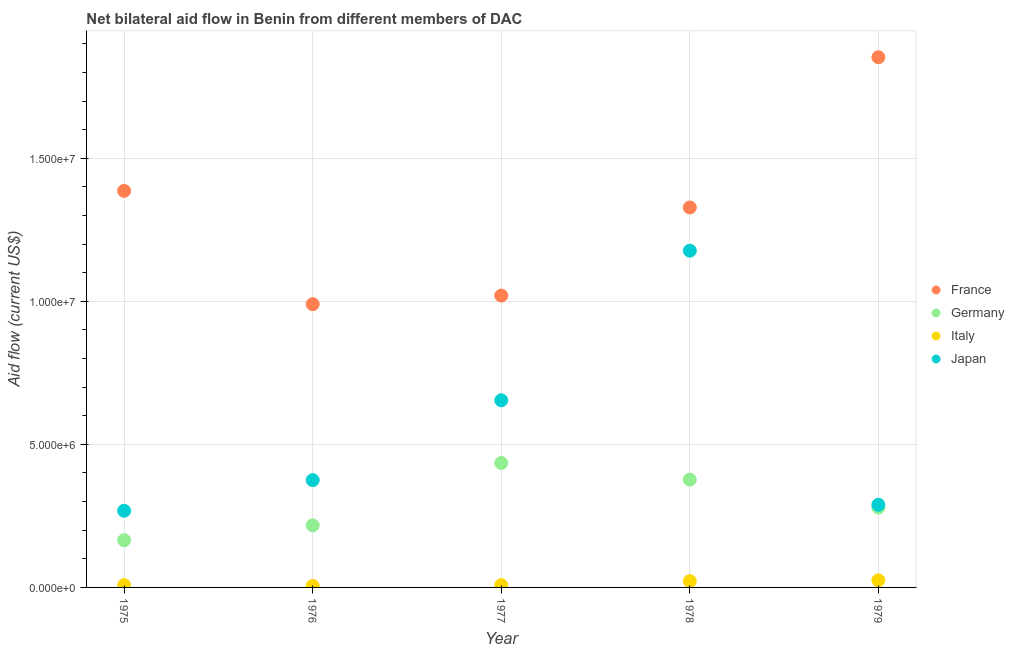How many different coloured dotlines are there?
Keep it short and to the point. 4. Is the number of dotlines equal to the number of legend labels?
Your response must be concise. Yes. What is the amount of aid given by germany in 1979?
Provide a short and direct response. 2.79e+06. Across all years, what is the maximum amount of aid given by germany?
Keep it short and to the point. 4.35e+06. Across all years, what is the minimum amount of aid given by germany?
Provide a short and direct response. 1.65e+06. In which year was the amount of aid given by italy maximum?
Make the answer very short. 1979. In which year was the amount of aid given by france minimum?
Your answer should be compact. 1976. What is the total amount of aid given by germany in the graph?
Offer a terse response. 1.47e+07. What is the difference between the amount of aid given by italy in 1975 and that in 1979?
Offer a very short reply. -1.70e+05. What is the difference between the amount of aid given by germany in 1979 and the amount of aid given by italy in 1976?
Give a very brief answer. 2.74e+06. What is the average amount of aid given by germany per year?
Give a very brief answer. 2.95e+06. In the year 1977, what is the difference between the amount of aid given by italy and amount of aid given by japan?
Provide a short and direct response. -6.46e+06. What is the ratio of the amount of aid given by germany in 1977 to that in 1979?
Your response must be concise. 1.56. What is the difference between the highest and the second highest amount of aid given by germany?
Your response must be concise. 5.80e+05. What is the difference between the highest and the lowest amount of aid given by japan?
Keep it short and to the point. 9.09e+06. In how many years, is the amount of aid given by italy greater than the average amount of aid given by italy taken over all years?
Ensure brevity in your answer.  2. Is the sum of the amount of aid given by france in 1976 and 1977 greater than the maximum amount of aid given by germany across all years?
Your response must be concise. Yes. How many dotlines are there?
Provide a short and direct response. 4. How many years are there in the graph?
Offer a terse response. 5. Are the values on the major ticks of Y-axis written in scientific E-notation?
Your answer should be very brief. Yes. Does the graph contain any zero values?
Give a very brief answer. No. Does the graph contain grids?
Give a very brief answer. Yes. How are the legend labels stacked?
Keep it short and to the point. Vertical. What is the title of the graph?
Make the answer very short. Net bilateral aid flow in Benin from different members of DAC. What is the label or title of the X-axis?
Give a very brief answer. Year. What is the label or title of the Y-axis?
Ensure brevity in your answer.  Aid flow (current US$). What is the Aid flow (current US$) in France in 1975?
Your response must be concise. 1.39e+07. What is the Aid flow (current US$) in Germany in 1975?
Your response must be concise. 1.65e+06. What is the Aid flow (current US$) in Italy in 1975?
Offer a terse response. 8.00e+04. What is the Aid flow (current US$) of Japan in 1975?
Offer a very short reply. 2.68e+06. What is the Aid flow (current US$) in France in 1976?
Offer a very short reply. 9.90e+06. What is the Aid flow (current US$) in Germany in 1976?
Your answer should be compact. 2.17e+06. What is the Aid flow (current US$) of Japan in 1976?
Your answer should be very brief. 3.75e+06. What is the Aid flow (current US$) in France in 1977?
Give a very brief answer. 1.02e+07. What is the Aid flow (current US$) in Germany in 1977?
Your answer should be very brief. 4.35e+06. What is the Aid flow (current US$) in Italy in 1977?
Make the answer very short. 8.00e+04. What is the Aid flow (current US$) in Japan in 1977?
Offer a terse response. 6.54e+06. What is the Aid flow (current US$) in France in 1978?
Your response must be concise. 1.33e+07. What is the Aid flow (current US$) of Germany in 1978?
Keep it short and to the point. 3.77e+06. What is the Aid flow (current US$) of Italy in 1978?
Provide a succinct answer. 2.20e+05. What is the Aid flow (current US$) in Japan in 1978?
Your answer should be compact. 1.18e+07. What is the Aid flow (current US$) in France in 1979?
Your answer should be very brief. 1.85e+07. What is the Aid flow (current US$) in Germany in 1979?
Your answer should be very brief. 2.79e+06. What is the Aid flow (current US$) of Japan in 1979?
Your answer should be very brief. 2.89e+06. Across all years, what is the maximum Aid flow (current US$) in France?
Offer a very short reply. 1.85e+07. Across all years, what is the maximum Aid flow (current US$) in Germany?
Offer a very short reply. 4.35e+06. Across all years, what is the maximum Aid flow (current US$) in Japan?
Your answer should be very brief. 1.18e+07. Across all years, what is the minimum Aid flow (current US$) in France?
Your answer should be very brief. 9.90e+06. Across all years, what is the minimum Aid flow (current US$) in Germany?
Keep it short and to the point. 1.65e+06. Across all years, what is the minimum Aid flow (current US$) of Italy?
Your answer should be compact. 5.00e+04. Across all years, what is the minimum Aid flow (current US$) of Japan?
Your answer should be compact. 2.68e+06. What is the total Aid flow (current US$) of France in the graph?
Keep it short and to the point. 6.58e+07. What is the total Aid flow (current US$) of Germany in the graph?
Provide a succinct answer. 1.47e+07. What is the total Aid flow (current US$) of Italy in the graph?
Give a very brief answer. 6.80e+05. What is the total Aid flow (current US$) of Japan in the graph?
Give a very brief answer. 2.76e+07. What is the difference between the Aid flow (current US$) in France in 1975 and that in 1976?
Your answer should be compact. 3.96e+06. What is the difference between the Aid flow (current US$) of Germany in 1975 and that in 1976?
Offer a very short reply. -5.20e+05. What is the difference between the Aid flow (current US$) in Italy in 1975 and that in 1976?
Provide a short and direct response. 3.00e+04. What is the difference between the Aid flow (current US$) of Japan in 1975 and that in 1976?
Ensure brevity in your answer.  -1.07e+06. What is the difference between the Aid flow (current US$) in France in 1975 and that in 1977?
Make the answer very short. 3.66e+06. What is the difference between the Aid flow (current US$) in Germany in 1975 and that in 1977?
Your answer should be compact. -2.70e+06. What is the difference between the Aid flow (current US$) in Italy in 1975 and that in 1977?
Give a very brief answer. 0. What is the difference between the Aid flow (current US$) in Japan in 1975 and that in 1977?
Ensure brevity in your answer.  -3.86e+06. What is the difference between the Aid flow (current US$) in France in 1975 and that in 1978?
Your response must be concise. 5.80e+05. What is the difference between the Aid flow (current US$) of Germany in 1975 and that in 1978?
Keep it short and to the point. -2.12e+06. What is the difference between the Aid flow (current US$) of Italy in 1975 and that in 1978?
Your answer should be compact. -1.40e+05. What is the difference between the Aid flow (current US$) in Japan in 1975 and that in 1978?
Make the answer very short. -9.09e+06. What is the difference between the Aid flow (current US$) of France in 1975 and that in 1979?
Your response must be concise. -4.67e+06. What is the difference between the Aid flow (current US$) of Germany in 1975 and that in 1979?
Your answer should be compact. -1.14e+06. What is the difference between the Aid flow (current US$) of France in 1976 and that in 1977?
Your answer should be compact. -3.00e+05. What is the difference between the Aid flow (current US$) of Germany in 1976 and that in 1977?
Your answer should be compact. -2.18e+06. What is the difference between the Aid flow (current US$) of Japan in 1976 and that in 1977?
Your response must be concise. -2.79e+06. What is the difference between the Aid flow (current US$) of France in 1976 and that in 1978?
Offer a very short reply. -3.38e+06. What is the difference between the Aid flow (current US$) in Germany in 1976 and that in 1978?
Keep it short and to the point. -1.60e+06. What is the difference between the Aid flow (current US$) in Italy in 1976 and that in 1978?
Your answer should be very brief. -1.70e+05. What is the difference between the Aid flow (current US$) of Japan in 1976 and that in 1978?
Keep it short and to the point. -8.02e+06. What is the difference between the Aid flow (current US$) of France in 1976 and that in 1979?
Offer a very short reply. -8.63e+06. What is the difference between the Aid flow (current US$) in Germany in 1976 and that in 1979?
Offer a very short reply. -6.20e+05. What is the difference between the Aid flow (current US$) in Japan in 1976 and that in 1979?
Offer a very short reply. 8.60e+05. What is the difference between the Aid flow (current US$) of France in 1977 and that in 1978?
Keep it short and to the point. -3.08e+06. What is the difference between the Aid flow (current US$) of Germany in 1977 and that in 1978?
Make the answer very short. 5.80e+05. What is the difference between the Aid flow (current US$) of Japan in 1977 and that in 1978?
Offer a terse response. -5.23e+06. What is the difference between the Aid flow (current US$) of France in 1977 and that in 1979?
Provide a short and direct response. -8.33e+06. What is the difference between the Aid flow (current US$) in Germany in 1977 and that in 1979?
Your answer should be compact. 1.56e+06. What is the difference between the Aid flow (current US$) of Japan in 1977 and that in 1979?
Your answer should be compact. 3.65e+06. What is the difference between the Aid flow (current US$) of France in 1978 and that in 1979?
Ensure brevity in your answer.  -5.25e+06. What is the difference between the Aid flow (current US$) of Germany in 1978 and that in 1979?
Offer a very short reply. 9.80e+05. What is the difference between the Aid flow (current US$) in Japan in 1978 and that in 1979?
Offer a very short reply. 8.88e+06. What is the difference between the Aid flow (current US$) in France in 1975 and the Aid flow (current US$) in Germany in 1976?
Provide a short and direct response. 1.17e+07. What is the difference between the Aid flow (current US$) in France in 1975 and the Aid flow (current US$) in Italy in 1976?
Your response must be concise. 1.38e+07. What is the difference between the Aid flow (current US$) of France in 1975 and the Aid flow (current US$) of Japan in 1976?
Give a very brief answer. 1.01e+07. What is the difference between the Aid flow (current US$) in Germany in 1975 and the Aid flow (current US$) in Italy in 1976?
Offer a very short reply. 1.60e+06. What is the difference between the Aid flow (current US$) of Germany in 1975 and the Aid flow (current US$) of Japan in 1976?
Your answer should be compact. -2.10e+06. What is the difference between the Aid flow (current US$) of Italy in 1975 and the Aid flow (current US$) of Japan in 1976?
Give a very brief answer. -3.67e+06. What is the difference between the Aid flow (current US$) of France in 1975 and the Aid flow (current US$) of Germany in 1977?
Your answer should be compact. 9.51e+06. What is the difference between the Aid flow (current US$) in France in 1975 and the Aid flow (current US$) in Italy in 1977?
Keep it short and to the point. 1.38e+07. What is the difference between the Aid flow (current US$) of France in 1975 and the Aid flow (current US$) of Japan in 1977?
Make the answer very short. 7.32e+06. What is the difference between the Aid flow (current US$) in Germany in 1975 and the Aid flow (current US$) in Italy in 1977?
Your response must be concise. 1.57e+06. What is the difference between the Aid flow (current US$) of Germany in 1975 and the Aid flow (current US$) of Japan in 1977?
Give a very brief answer. -4.89e+06. What is the difference between the Aid flow (current US$) of Italy in 1975 and the Aid flow (current US$) of Japan in 1977?
Your answer should be compact. -6.46e+06. What is the difference between the Aid flow (current US$) of France in 1975 and the Aid flow (current US$) of Germany in 1978?
Provide a succinct answer. 1.01e+07. What is the difference between the Aid flow (current US$) in France in 1975 and the Aid flow (current US$) in Italy in 1978?
Offer a terse response. 1.36e+07. What is the difference between the Aid flow (current US$) of France in 1975 and the Aid flow (current US$) of Japan in 1978?
Make the answer very short. 2.09e+06. What is the difference between the Aid flow (current US$) in Germany in 1975 and the Aid flow (current US$) in Italy in 1978?
Give a very brief answer. 1.43e+06. What is the difference between the Aid flow (current US$) in Germany in 1975 and the Aid flow (current US$) in Japan in 1978?
Provide a short and direct response. -1.01e+07. What is the difference between the Aid flow (current US$) of Italy in 1975 and the Aid flow (current US$) of Japan in 1978?
Offer a terse response. -1.17e+07. What is the difference between the Aid flow (current US$) of France in 1975 and the Aid flow (current US$) of Germany in 1979?
Offer a very short reply. 1.11e+07. What is the difference between the Aid flow (current US$) of France in 1975 and the Aid flow (current US$) of Italy in 1979?
Make the answer very short. 1.36e+07. What is the difference between the Aid flow (current US$) of France in 1975 and the Aid flow (current US$) of Japan in 1979?
Your answer should be compact. 1.10e+07. What is the difference between the Aid flow (current US$) of Germany in 1975 and the Aid flow (current US$) of Italy in 1979?
Your response must be concise. 1.40e+06. What is the difference between the Aid flow (current US$) of Germany in 1975 and the Aid flow (current US$) of Japan in 1979?
Provide a short and direct response. -1.24e+06. What is the difference between the Aid flow (current US$) of Italy in 1975 and the Aid flow (current US$) of Japan in 1979?
Give a very brief answer. -2.81e+06. What is the difference between the Aid flow (current US$) in France in 1976 and the Aid flow (current US$) in Germany in 1977?
Offer a terse response. 5.55e+06. What is the difference between the Aid flow (current US$) in France in 1976 and the Aid flow (current US$) in Italy in 1977?
Give a very brief answer. 9.82e+06. What is the difference between the Aid flow (current US$) in France in 1976 and the Aid flow (current US$) in Japan in 1977?
Your response must be concise. 3.36e+06. What is the difference between the Aid flow (current US$) of Germany in 1976 and the Aid flow (current US$) of Italy in 1977?
Your answer should be compact. 2.09e+06. What is the difference between the Aid flow (current US$) in Germany in 1976 and the Aid flow (current US$) in Japan in 1977?
Ensure brevity in your answer.  -4.37e+06. What is the difference between the Aid flow (current US$) of Italy in 1976 and the Aid flow (current US$) of Japan in 1977?
Provide a short and direct response. -6.49e+06. What is the difference between the Aid flow (current US$) in France in 1976 and the Aid flow (current US$) in Germany in 1978?
Make the answer very short. 6.13e+06. What is the difference between the Aid flow (current US$) of France in 1976 and the Aid flow (current US$) of Italy in 1978?
Give a very brief answer. 9.68e+06. What is the difference between the Aid flow (current US$) in France in 1976 and the Aid flow (current US$) in Japan in 1978?
Make the answer very short. -1.87e+06. What is the difference between the Aid flow (current US$) in Germany in 1976 and the Aid flow (current US$) in Italy in 1978?
Make the answer very short. 1.95e+06. What is the difference between the Aid flow (current US$) of Germany in 1976 and the Aid flow (current US$) of Japan in 1978?
Your answer should be very brief. -9.60e+06. What is the difference between the Aid flow (current US$) in Italy in 1976 and the Aid flow (current US$) in Japan in 1978?
Keep it short and to the point. -1.17e+07. What is the difference between the Aid flow (current US$) of France in 1976 and the Aid flow (current US$) of Germany in 1979?
Your answer should be compact. 7.11e+06. What is the difference between the Aid flow (current US$) of France in 1976 and the Aid flow (current US$) of Italy in 1979?
Give a very brief answer. 9.65e+06. What is the difference between the Aid flow (current US$) of France in 1976 and the Aid flow (current US$) of Japan in 1979?
Your answer should be very brief. 7.01e+06. What is the difference between the Aid flow (current US$) in Germany in 1976 and the Aid flow (current US$) in Italy in 1979?
Offer a terse response. 1.92e+06. What is the difference between the Aid flow (current US$) in Germany in 1976 and the Aid flow (current US$) in Japan in 1979?
Make the answer very short. -7.20e+05. What is the difference between the Aid flow (current US$) of Italy in 1976 and the Aid flow (current US$) of Japan in 1979?
Offer a terse response. -2.84e+06. What is the difference between the Aid flow (current US$) in France in 1977 and the Aid flow (current US$) in Germany in 1978?
Ensure brevity in your answer.  6.43e+06. What is the difference between the Aid flow (current US$) in France in 1977 and the Aid flow (current US$) in Italy in 1978?
Ensure brevity in your answer.  9.98e+06. What is the difference between the Aid flow (current US$) in France in 1977 and the Aid flow (current US$) in Japan in 1978?
Provide a short and direct response. -1.57e+06. What is the difference between the Aid flow (current US$) of Germany in 1977 and the Aid flow (current US$) of Italy in 1978?
Keep it short and to the point. 4.13e+06. What is the difference between the Aid flow (current US$) in Germany in 1977 and the Aid flow (current US$) in Japan in 1978?
Give a very brief answer. -7.42e+06. What is the difference between the Aid flow (current US$) in Italy in 1977 and the Aid flow (current US$) in Japan in 1978?
Keep it short and to the point. -1.17e+07. What is the difference between the Aid flow (current US$) of France in 1977 and the Aid flow (current US$) of Germany in 1979?
Offer a very short reply. 7.41e+06. What is the difference between the Aid flow (current US$) of France in 1977 and the Aid flow (current US$) of Italy in 1979?
Give a very brief answer. 9.95e+06. What is the difference between the Aid flow (current US$) in France in 1977 and the Aid flow (current US$) in Japan in 1979?
Provide a succinct answer. 7.31e+06. What is the difference between the Aid flow (current US$) in Germany in 1977 and the Aid flow (current US$) in Italy in 1979?
Keep it short and to the point. 4.10e+06. What is the difference between the Aid flow (current US$) of Germany in 1977 and the Aid flow (current US$) of Japan in 1979?
Offer a very short reply. 1.46e+06. What is the difference between the Aid flow (current US$) of Italy in 1977 and the Aid flow (current US$) of Japan in 1979?
Make the answer very short. -2.81e+06. What is the difference between the Aid flow (current US$) of France in 1978 and the Aid flow (current US$) of Germany in 1979?
Your answer should be compact. 1.05e+07. What is the difference between the Aid flow (current US$) in France in 1978 and the Aid flow (current US$) in Italy in 1979?
Your answer should be compact. 1.30e+07. What is the difference between the Aid flow (current US$) of France in 1978 and the Aid flow (current US$) of Japan in 1979?
Provide a short and direct response. 1.04e+07. What is the difference between the Aid flow (current US$) in Germany in 1978 and the Aid flow (current US$) in Italy in 1979?
Ensure brevity in your answer.  3.52e+06. What is the difference between the Aid flow (current US$) in Germany in 1978 and the Aid flow (current US$) in Japan in 1979?
Provide a succinct answer. 8.80e+05. What is the difference between the Aid flow (current US$) in Italy in 1978 and the Aid flow (current US$) in Japan in 1979?
Keep it short and to the point. -2.67e+06. What is the average Aid flow (current US$) of France per year?
Keep it short and to the point. 1.32e+07. What is the average Aid flow (current US$) in Germany per year?
Provide a short and direct response. 2.95e+06. What is the average Aid flow (current US$) of Italy per year?
Offer a very short reply. 1.36e+05. What is the average Aid flow (current US$) of Japan per year?
Make the answer very short. 5.53e+06. In the year 1975, what is the difference between the Aid flow (current US$) in France and Aid flow (current US$) in Germany?
Offer a very short reply. 1.22e+07. In the year 1975, what is the difference between the Aid flow (current US$) in France and Aid flow (current US$) in Italy?
Offer a very short reply. 1.38e+07. In the year 1975, what is the difference between the Aid flow (current US$) of France and Aid flow (current US$) of Japan?
Ensure brevity in your answer.  1.12e+07. In the year 1975, what is the difference between the Aid flow (current US$) of Germany and Aid flow (current US$) of Italy?
Give a very brief answer. 1.57e+06. In the year 1975, what is the difference between the Aid flow (current US$) of Germany and Aid flow (current US$) of Japan?
Offer a terse response. -1.03e+06. In the year 1975, what is the difference between the Aid flow (current US$) in Italy and Aid flow (current US$) in Japan?
Your response must be concise. -2.60e+06. In the year 1976, what is the difference between the Aid flow (current US$) of France and Aid flow (current US$) of Germany?
Your answer should be very brief. 7.73e+06. In the year 1976, what is the difference between the Aid flow (current US$) in France and Aid flow (current US$) in Italy?
Your answer should be compact. 9.85e+06. In the year 1976, what is the difference between the Aid flow (current US$) of France and Aid flow (current US$) of Japan?
Offer a very short reply. 6.15e+06. In the year 1976, what is the difference between the Aid flow (current US$) in Germany and Aid flow (current US$) in Italy?
Ensure brevity in your answer.  2.12e+06. In the year 1976, what is the difference between the Aid flow (current US$) in Germany and Aid flow (current US$) in Japan?
Give a very brief answer. -1.58e+06. In the year 1976, what is the difference between the Aid flow (current US$) in Italy and Aid flow (current US$) in Japan?
Your answer should be compact. -3.70e+06. In the year 1977, what is the difference between the Aid flow (current US$) in France and Aid flow (current US$) in Germany?
Make the answer very short. 5.85e+06. In the year 1977, what is the difference between the Aid flow (current US$) of France and Aid flow (current US$) of Italy?
Make the answer very short. 1.01e+07. In the year 1977, what is the difference between the Aid flow (current US$) of France and Aid flow (current US$) of Japan?
Make the answer very short. 3.66e+06. In the year 1977, what is the difference between the Aid flow (current US$) of Germany and Aid flow (current US$) of Italy?
Ensure brevity in your answer.  4.27e+06. In the year 1977, what is the difference between the Aid flow (current US$) of Germany and Aid flow (current US$) of Japan?
Your answer should be very brief. -2.19e+06. In the year 1977, what is the difference between the Aid flow (current US$) of Italy and Aid flow (current US$) of Japan?
Make the answer very short. -6.46e+06. In the year 1978, what is the difference between the Aid flow (current US$) of France and Aid flow (current US$) of Germany?
Give a very brief answer. 9.51e+06. In the year 1978, what is the difference between the Aid flow (current US$) in France and Aid flow (current US$) in Italy?
Keep it short and to the point. 1.31e+07. In the year 1978, what is the difference between the Aid flow (current US$) of France and Aid flow (current US$) of Japan?
Your answer should be very brief. 1.51e+06. In the year 1978, what is the difference between the Aid flow (current US$) of Germany and Aid flow (current US$) of Italy?
Offer a very short reply. 3.55e+06. In the year 1978, what is the difference between the Aid flow (current US$) of Germany and Aid flow (current US$) of Japan?
Ensure brevity in your answer.  -8.00e+06. In the year 1978, what is the difference between the Aid flow (current US$) in Italy and Aid flow (current US$) in Japan?
Keep it short and to the point. -1.16e+07. In the year 1979, what is the difference between the Aid flow (current US$) in France and Aid flow (current US$) in Germany?
Provide a succinct answer. 1.57e+07. In the year 1979, what is the difference between the Aid flow (current US$) in France and Aid flow (current US$) in Italy?
Give a very brief answer. 1.83e+07. In the year 1979, what is the difference between the Aid flow (current US$) of France and Aid flow (current US$) of Japan?
Keep it short and to the point. 1.56e+07. In the year 1979, what is the difference between the Aid flow (current US$) of Germany and Aid flow (current US$) of Italy?
Provide a short and direct response. 2.54e+06. In the year 1979, what is the difference between the Aid flow (current US$) of Italy and Aid flow (current US$) of Japan?
Give a very brief answer. -2.64e+06. What is the ratio of the Aid flow (current US$) of France in 1975 to that in 1976?
Ensure brevity in your answer.  1.4. What is the ratio of the Aid flow (current US$) in Germany in 1975 to that in 1976?
Provide a short and direct response. 0.76. What is the ratio of the Aid flow (current US$) of Japan in 1975 to that in 1976?
Provide a short and direct response. 0.71. What is the ratio of the Aid flow (current US$) in France in 1975 to that in 1977?
Your answer should be compact. 1.36. What is the ratio of the Aid flow (current US$) of Germany in 1975 to that in 1977?
Provide a succinct answer. 0.38. What is the ratio of the Aid flow (current US$) of Japan in 1975 to that in 1977?
Provide a short and direct response. 0.41. What is the ratio of the Aid flow (current US$) in France in 1975 to that in 1978?
Make the answer very short. 1.04. What is the ratio of the Aid flow (current US$) in Germany in 1975 to that in 1978?
Your answer should be very brief. 0.44. What is the ratio of the Aid flow (current US$) in Italy in 1975 to that in 1978?
Provide a short and direct response. 0.36. What is the ratio of the Aid flow (current US$) in Japan in 1975 to that in 1978?
Offer a terse response. 0.23. What is the ratio of the Aid flow (current US$) in France in 1975 to that in 1979?
Your answer should be compact. 0.75. What is the ratio of the Aid flow (current US$) of Germany in 1975 to that in 1979?
Make the answer very short. 0.59. What is the ratio of the Aid flow (current US$) in Italy in 1975 to that in 1979?
Make the answer very short. 0.32. What is the ratio of the Aid flow (current US$) of Japan in 1975 to that in 1979?
Ensure brevity in your answer.  0.93. What is the ratio of the Aid flow (current US$) of France in 1976 to that in 1977?
Your response must be concise. 0.97. What is the ratio of the Aid flow (current US$) in Germany in 1976 to that in 1977?
Keep it short and to the point. 0.5. What is the ratio of the Aid flow (current US$) in Italy in 1976 to that in 1977?
Keep it short and to the point. 0.62. What is the ratio of the Aid flow (current US$) of Japan in 1976 to that in 1977?
Offer a terse response. 0.57. What is the ratio of the Aid flow (current US$) of France in 1976 to that in 1978?
Offer a terse response. 0.75. What is the ratio of the Aid flow (current US$) in Germany in 1976 to that in 1978?
Provide a short and direct response. 0.58. What is the ratio of the Aid flow (current US$) in Italy in 1976 to that in 1978?
Your response must be concise. 0.23. What is the ratio of the Aid flow (current US$) of Japan in 1976 to that in 1978?
Your answer should be compact. 0.32. What is the ratio of the Aid flow (current US$) in France in 1976 to that in 1979?
Provide a short and direct response. 0.53. What is the ratio of the Aid flow (current US$) of Germany in 1976 to that in 1979?
Your answer should be compact. 0.78. What is the ratio of the Aid flow (current US$) of Italy in 1976 to that in 1979?
Provide a short and direct response. 0.2. What is the ratio of the Aid flow (current US$) of Japan in 1976 to that in 1979?
Make the answer very short. 1.3. What is the ratio of the Aid flow (current US$) of France in 1977 to that in 1978?
Make the answer very short. 0.77. What is the ratio of the Aid flow (current US$) in Germany in 1977 to that in 1978?
Ensure brevity in your answer.  1.15. What is the ratio of the Aid flow (current US$) in Italy in 1977 to that in 1978?
Your answer should be very brief. 0.36. What is the ratio of the Aid flow (current US$) in Japan in 1977 to that in 1978?
Provide a short and direct response. 0.56. What is the ratio of the Aid flow (current US$) of France in 1977 to that in 1979?
Offer a very short reply. 0.55. What is the ratio of the Aid flow (current US$) in Germany in 1977 to that in 1979?
Provide a short and direct response. 1.56. What is the ratio of the Aid flow (current US$) of Italy in 1977 to that in 1979?
Your answer should be very brief. 0.32. What is the ratio of the Aid flow (current US$) in Japan in 1977 to that in 1979?
Provide a succinct answer. 2.26. What is the ratio of the Aid flow (current US$) in France in 1978 to that in 1979?
Offer a very short reply. 0.72. What is the ratio of the Aid flow (current US$) in Germany in 1978 to that in 1979?
Give a very brief answer. 1.35. What is the ratio of the Aid flow (current US$) of Japan in 1978 to that in 1979?
Make the answer very short. 4.07. What is the difference between the highest and the second highest Aid flow (current US$) in France?
Your response must be concise. 4.67e+06. What is the difference between the highest and the second highest Aid flow (current US$) of Germany?
Provide a short and direct response. 5.80e+05. What is the difference between the highest and the second highest Aid flow (current US$) in Japan?
Offer a very short reply. 5.23e+06. What is the difference between the highest and the lowest Aid flow (current US$) in France?
Offer a terse response. 8.63e+06. What is the difference between the highest and the lowest Aid flow (current US$) of Germany?
Your answer should be very brief. 2.70e+06. What is the difference between the highest and the lowest Aid flow (current US$) of Italy?
Offer a terse response. 2.00e+05. What is the difference between the highest and the lowest Aid flow (current US$) of Japan?
Your answer should be compact. 9.09e+06. 